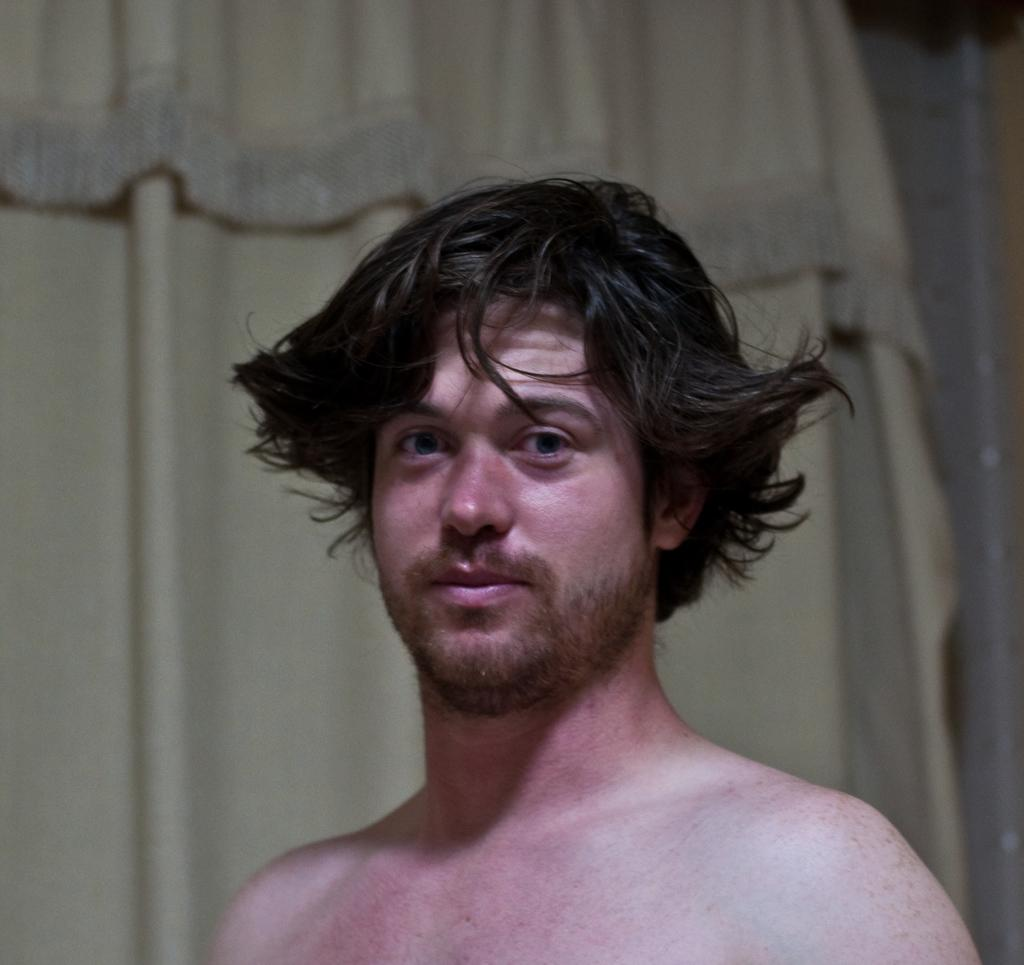What is the main subject of the image? There is a person in the image. Can you describe the background of the image? There is a curtain visible behind the person. What type of bread can be seen on the canvas in the image? There is no canvas or bread present in the image. Can you describe the snake's pattern on the person's clothing in the image? There is no snake or pattern mentioned in the image; it only features a person and a curtain. 